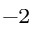Convert formula to latex. <formula><loc_0><loc_0><loc_500><loc_500>^ { - 2 }</formula> 